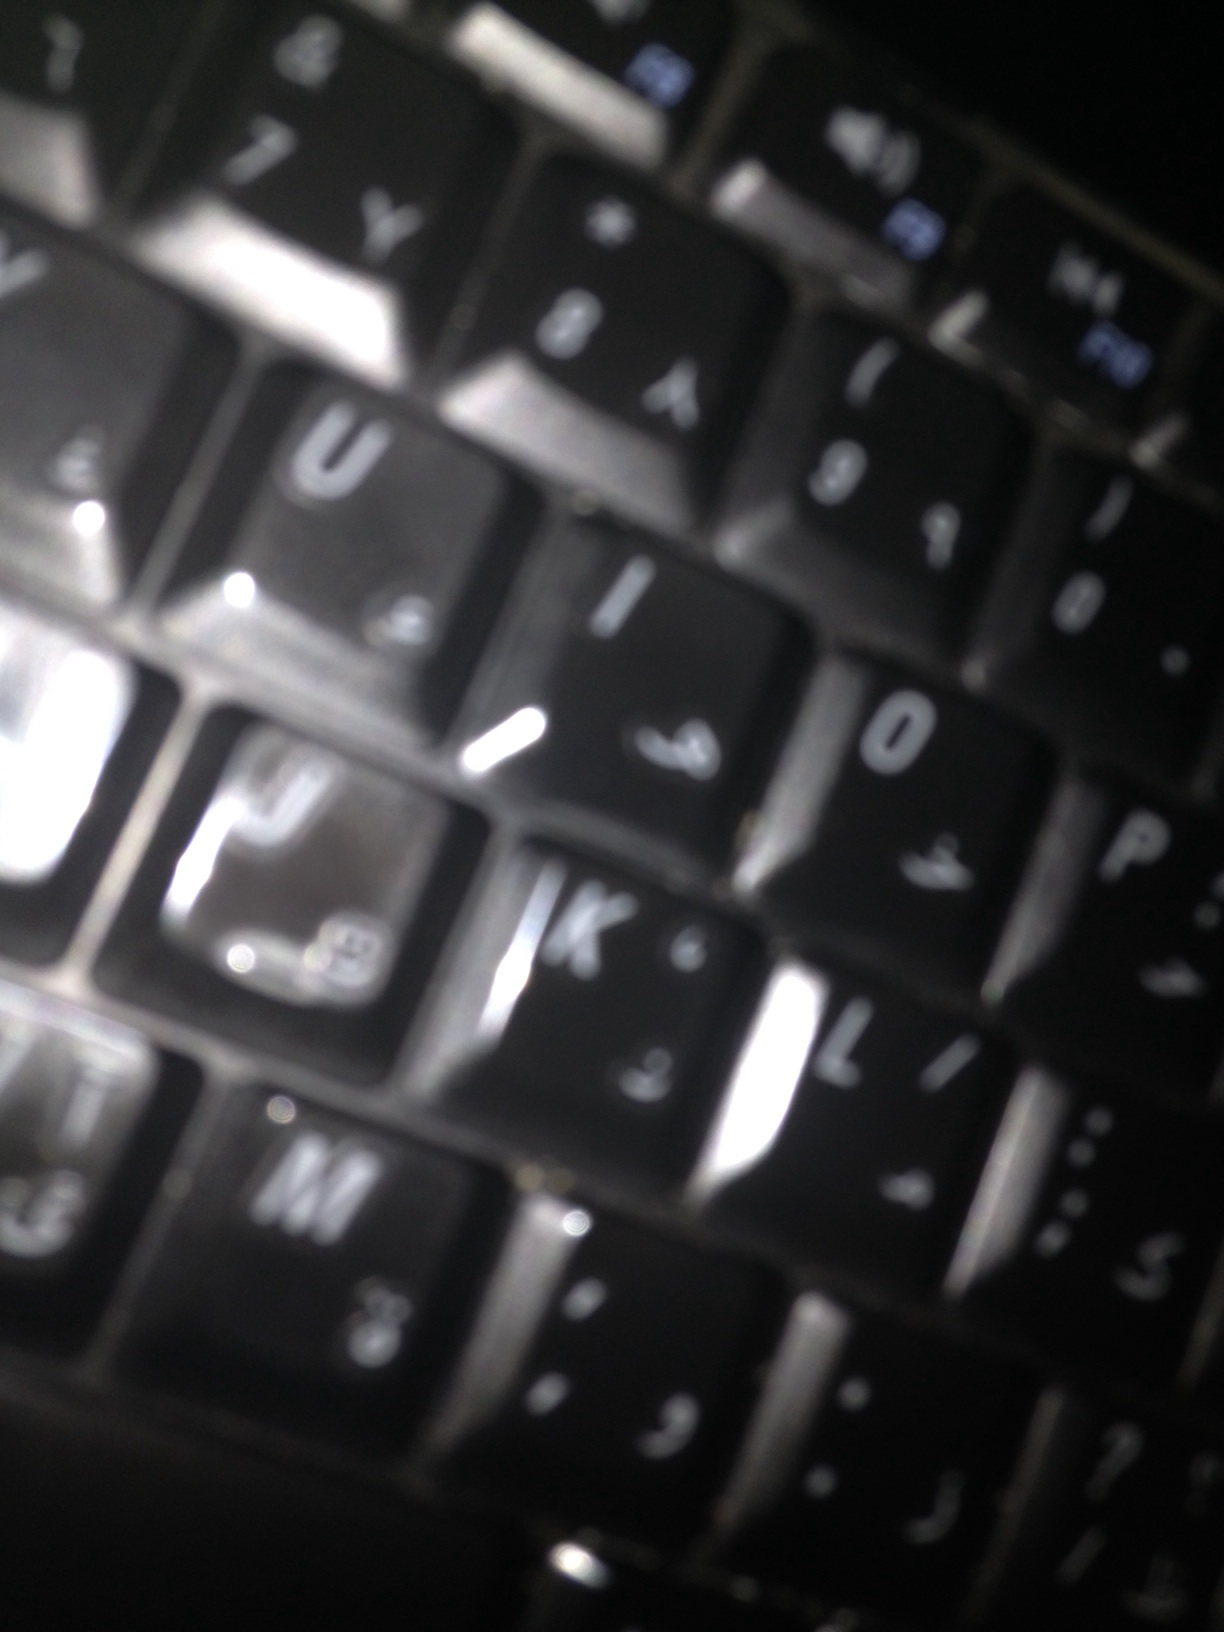Based on the image, create a relatable scenario where someone might be using this keyboard. A college student sits at their desk, working late into the night on a crucial term paper due the next day. The room is quiet except for the soft clicks of the keyboard keys. They pause occasionally to sip coffee and read through references, the bilingual keyboard making it easy to pull in sources from different languages. The student types furiously, racing against the clock to meet the deadline.  Given that this keyboard has both English and another language, how might it be used in a classroom setting? In a modern language classroom, students are learning how to type in both English and Arabic. The teacher explains the nuances of each language, and students practice by writing short essays and completing interactive typing games. The bilingual keyboard facilitates seamless switching between languages, helping students become proficient and confident in their language skills. It also serves as a cultural bridge, allowing students to better understand and appreciate the intricacies of both languages. 